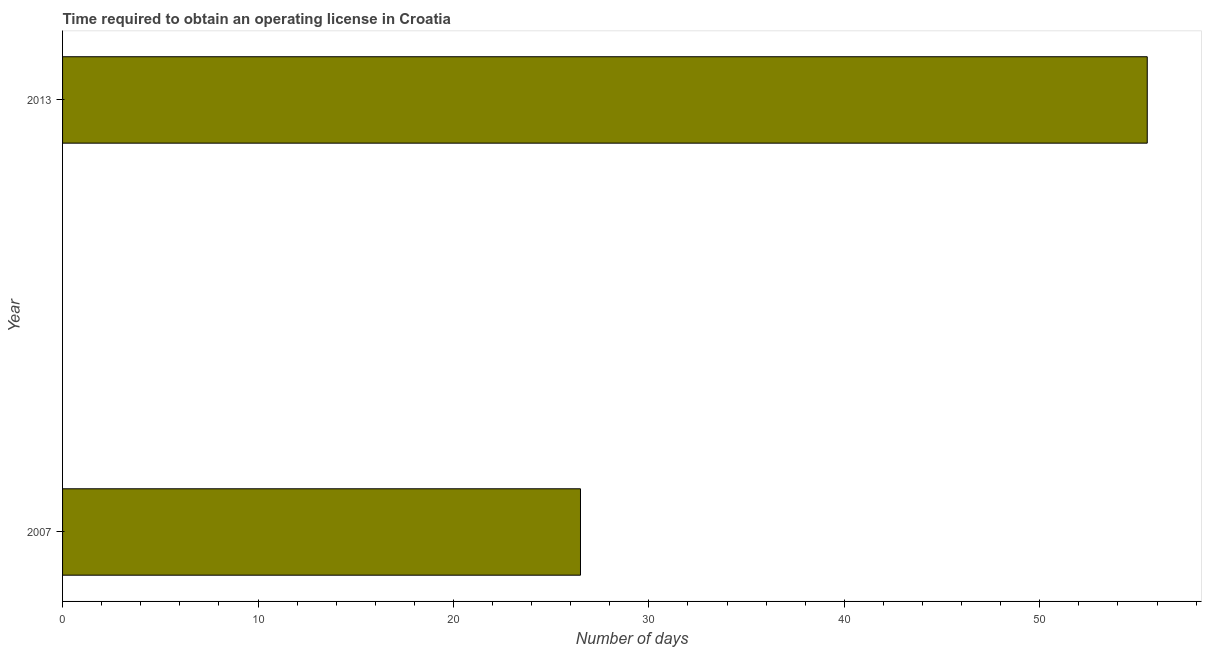Does the graph contain grids?
Your answer should be compact. No. What is the title of the graph?
Make the answer very short. Time required to obtain an operating license in Croatia. What is the label or title of the X-axis?
Offer a very short reply. Number of days. What is the label or title of the Y-axis?
Offer a terse response. Year. Across all years, what is the maximum number of days to obtain operating license?
Offer a very short reply. 55.5. In which year was the number of days to obtain operating license maximum?
Keep it short and to the point. 2013. What is the sum of the number of days to obtain operating license?
Keep it short and to the point. 82. What is the difference between the number of days to obtain operating license in 2007 and 2013?
Give a very brief answer. -29. What is the average number of days to obtain operating license per year?
Your answer should be compact. 41. Do a majority of the years between 2007 and 2013 (inclusive) have number of days to obtain operating license greater than 4 days?
Offer a terse response. Yes. What is the ratio of the number of days to obtain operating license in 2007 to that in 2013?
Your answer should be very brief. 0.48. Is the number of days to obtain operating license in 2007 less than that in 2013?
Make the answer very short. Yes. How many bars are there?
Make the answer very short. 2. Are all the bars in the graph horizontal?
Keep it short and to the point. Yes. What is the difference between two consecutive major ticks on the X-axis?
Give a very brief answer. 10. What is the Number of days of 2007?
Provide a succinct answer. 26.5. What is the Number of days of 2013?
Your response must be concise. 55.5. What is the ratio of the Number of days in 2007 to that in 2013?
Your response must be concise. 0.48. 